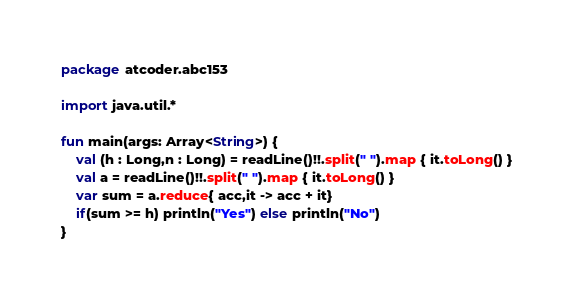<code> <loc_0><loc_0><loc_500><loc_500><_Kotlin_>package atcoder.abc153

import java.util.*

fun main(args: Array<String>) {
    val (h : Long,n : Long) = readLine()!!.split(" ").map { it.toLong() }
    val a = readLine()!!.split(" ").map { it.toLong() }
    var sum = a.reduce{ acc,it -> acc + it}
    if(sum >= h) println("Yes") else println("No")
}
</code> 